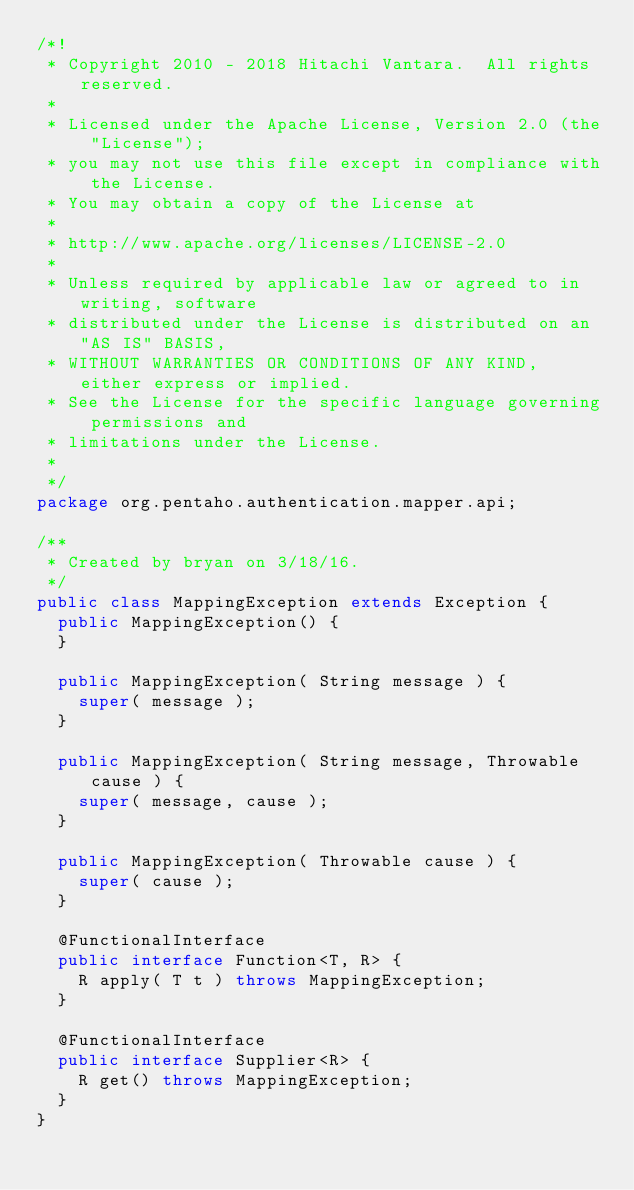<code> <loc_0><loc_0><loc_500><loc_500><_Java_>/*!
 * Copyright 2010 - 2018 Hitachi Vantara.  All rights reserved.
 *
 * Licensed under the Apache License, Version 2.0 (the "License");
 * you may not use this file except in compliance with the License.
 * You may obtain a copy of the License at
 *
 * http://www.apache.org/licenses/LICENSE-2.0
 *
 * Unless required by applicable law or agreed to in writing, software
 * distributed under the License is distributed on an "AS IS" BASIS,
 * WITHOUT WARRANTIES OR CONDITIONS OF ANY KIND, either express or implied.
 * See the License for the specific language governing permissions and
 * limitations under the License.
 *
 */
package org.pentaho.authentication.mapper.api;

/**
 * Created by bryan on 3/18/16.
 */
public class MappingException extends Exception {
  public MappingException() {
  }

  public MappingException( String message ) {
    super( message );
  }

  public MappingException( String message, Throwable cause ) {
    super( message, cause );
  }

  public MappingException( Throwable cause ) {
    super( cause );
  }

  @FunctionalInterface
  public interface Function<T, R> {
    R apply( T t ) throws MappingException;
  }

  @FunctionalInterface
  public interface Supplier<R> {
    R get() throws MappingException;
  }
}
</code> 